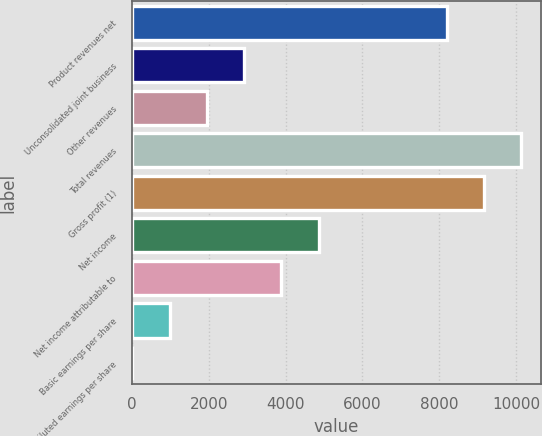Convert chart. <chart><loc_0><loc_0><loc_500><loc_500><bar_chart><fcel>Product revenues net<fcel>Unconsolidated joint business<fcel>Other revenues<fcel>Total revenues<fcel>Gross profit (1)<fcel>Net income<fcel>Net income attributable to<fcel>Basic earnings per share<fcel>Diluted earnings per share<nl><fcel>8203.4<fcel>2919.64<fcel>1950.55<fcel>10141.6<fcel>9172.49<fcel>4857.82<fcel>3888.73<fcel>981.46<fcel>12.37<nl></chart> 